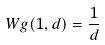Convert formula to latex. <formula><loc_0><loc_0><loc_500><loc_500>W g ( 1 , d ) = \frac { 1 } { d }</formula> 